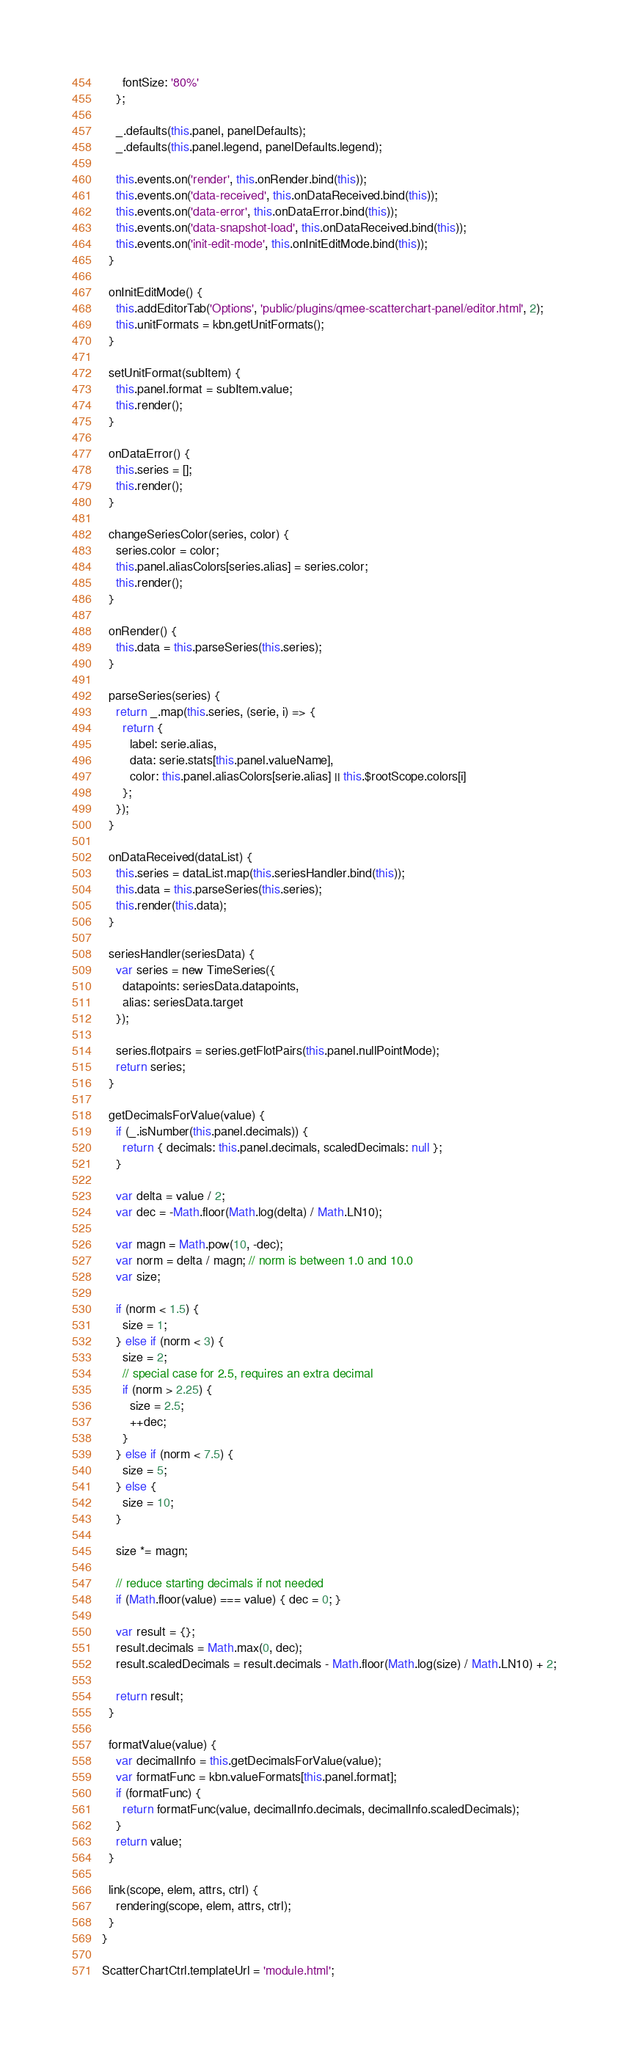Convert code to text. <code><loc_0><loc_0><loc_500><loc_500><_JavaScript_>      fontSize: '80%'
    };

    _.defaults(this.panel, panelDefaults);
    _.defaults(this.panel.legend, panelDefaults.legend);

    this.events.on('render', this.onRender.bind(this));
    this.events.on('data-received', this.onDataReceived.bind(this));
    this.events.on('data-error', this.onDataError.bind(this));
    this.events.on('data-snapshot-load', this.onDataReceived.bind(this));
    this.events.on('init-edit-mode', this.onInitEditMode.bind(this));
  }

  onInitEditMode() {
    this.addEditorTab('Options', 'public/plugins/qmee-scatterchart-panel/editor.html', 2);
    this.unitFormats = kbn.getUnitFormats();
  }

  setUnitFormat(subItem) {
    this.panel.format = subItem.value;
    this.render();
  }

  onDataError() {
    this.series = [];
    this.render();
  }

  changeSeriesColor(series, color) {
    series.color = color;
    this.panel.aliasColors[series.alias] = series.color;
    this.render();
  }

  onRender() {
    this.data = this.parseSeries(this.series);
  }

  parseSeries(series) {
    return _.map(this.series, (serie, i) => {
      return {
        label: serie.alias,
        data: serie.stats[this.panel.valueName],
        color: this.panel.aliasColors[serie.alias] || this.$rootScope.colors[i]
      };
    });
  }

  onDataReceived(dataList) {
    this.series = dataList.map(this.seriesHandler.bind(this));
    this.data = this.parseSeries(this.series);
    this.render(this.data);
  }

  seriesHandler(seriesData) {
    var series = new TimeSeries({
      datapoints: seriesData.datapoints,
      alias: seriesData.target
    });

    series.flotpairs = series.getFlotPairs(this.panel.nullPointMode);
    return series;
  }

  getDecimalsForValue(value) {
    if (_.isNumber(this.panel.decimals)) {
      return { decimals: this.panel.decimals, scaledDecimals: null };
    }

    var delta = value / 2;
    var dec = -Math.floor(Math.log(delta) / Math.LN10);

    var magn = Math.pow(10, -dec);
    var norm = delta / magn; // norm is between 1.0 and 10.0
    var size;

    if (norm < 1.5) {
      size = 1;
    } else if (norm < 3) {
      size = 2;
      // special case for 2.5, requires an extra decimal
      if (norm > 2.25) {
        size = 2.5;
        ++dec;
      }
    } else if (norm < 7.5) {
      size = 5;
    } else {
      size = 10;
    }

    size *= magn;

    // reduce starting decimals if not needed
    if (Math.floor(value) === value) { dec = 0; }

    var result = {};
    result.decimals = Math.max(0, dec);
    result.scaledDecimals = result.decimals - Math.floor(Math.log(size) / Math.LN10) + 2;

    return result;
  }

  formatValue(value) {
    var decimalInfo = this.getDecimalsForValue(value);
    var formatFunc = kbn.valueFormats[this.panel.format];
    if (formatFunc) {
      return formatFunc(value, decimalInfo.decimals, decimalInfo.scaledDecimals);
    }
    return value;
  }

  link(scope, elem, attrs, ctrl) {
    rendering(scope, elem, attrs, ctrl);
  }
}

ScatterChartCtrl.templateUrl = 'module.html';
</code> 